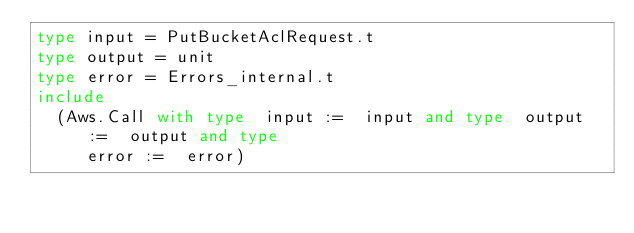Convert code to text. <code><loc_0><loc_0><loc_500><loc_500><_OCaml_>type input = PutBucketAclRequest.t
type output = unit
type error = Errors_internal.t
include
  (Aws.Call with type  input :=  input and type  output :=  output and type
     error :=  error)</code> 